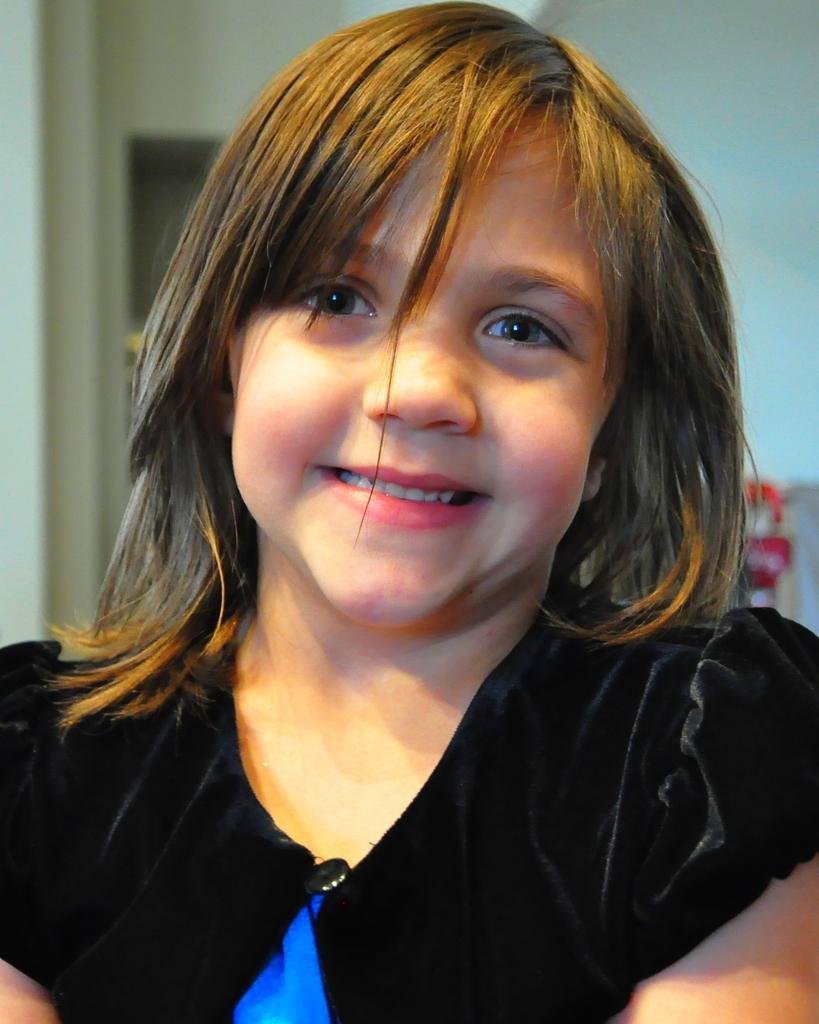Can you describe this image briefly? In the picture we can see a girl smiling, she is with a black dress, in the background we can see a wall. 